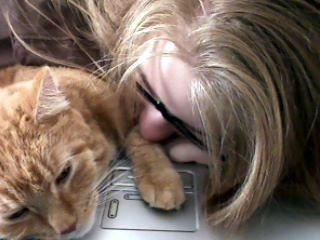Describe the objects in this image and their specific colors. I can see people in gray, black, and darkgray tones, cat in gray, tan, and maroon tones, and laptop in gray, darkgray, lightgray, and black tones in this image. 